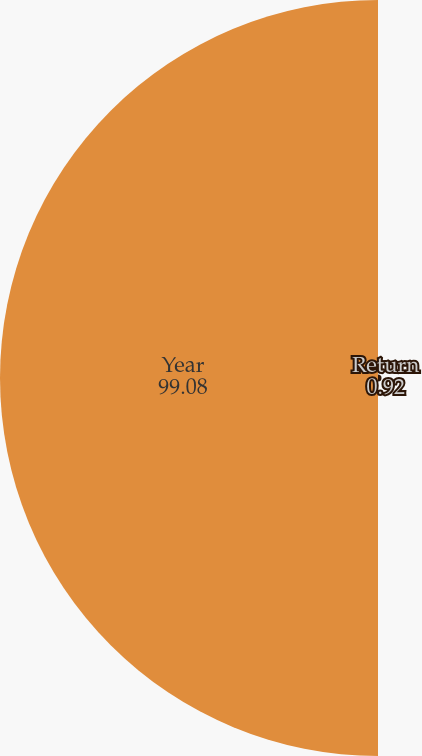Convert chart. <chart><loc_0><loc_0><loc_500><loc_500><pie_chart><fcel>Return<fcel>Year<nl><fcel>0.92%<fcel>99.08%<nl></chart> 